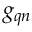<formula> <loc_0><loc_0><loc_500><loc_500>g _ { q n }</formula> 